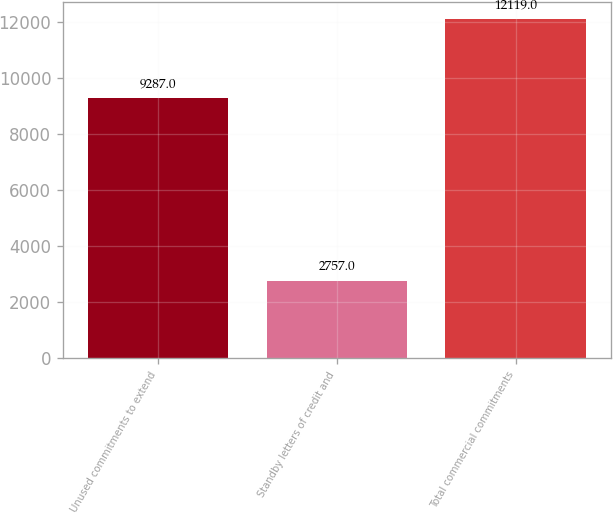<chart> <loc_0><loc_0><loc_500><loc_500><bar_chart><fcel>Unused commitments to extend<fcel>Standby letters of credit and<fcel>Total commercial commitments<nl><fcel>9287<fcel>2757<fcel>12119<nl></chart> 